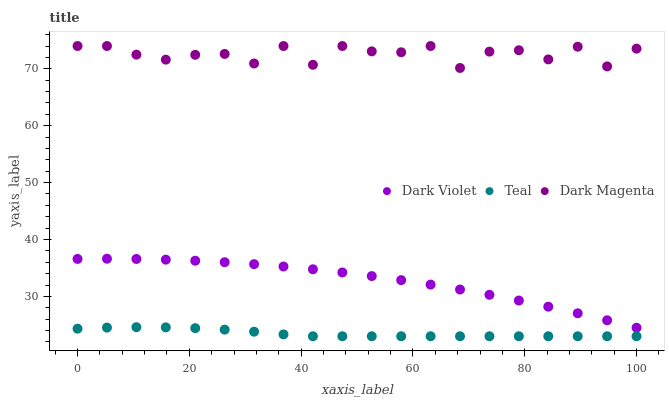Does Teal have the minimum area under the curve?
Answer yes or no. Yes. Does Dark Magenta have the maximum area under the curve?
Answer yes or no. Yes. Does Dark Violet have the minimum area under the curve?
Answer yes or no. No. Does Dark Violet have the maximum area under the curve?
Answer yes or no. No. Is Teal the smoothest?
Answer yes or no. Yes. Is Dark Magenta the roughest?
Answer yes or no. Yes. Is Dark Violet the smoothest?
Answer yes or no. No. Is Dark Violet the roughest?
Answer yes or no. No. Does Teal have the lowest value?
Answer yes or no. Yes. Does Dark Violet have the lowest value?
Answer yes or no. No. Does Dark Magenta have the highest value?
Answer yes or no. Yes. Does Dark Violet have the highest value?
Answer yes or no. No. Is Dark Violet less than Dark Magenta?
Answer yes or no. Yes. Is Dark Violet greater than Teal?
Answer yes or no. Yes. Does Dark Violet intersect Dark Magenta?
Answer yes or no. No. 